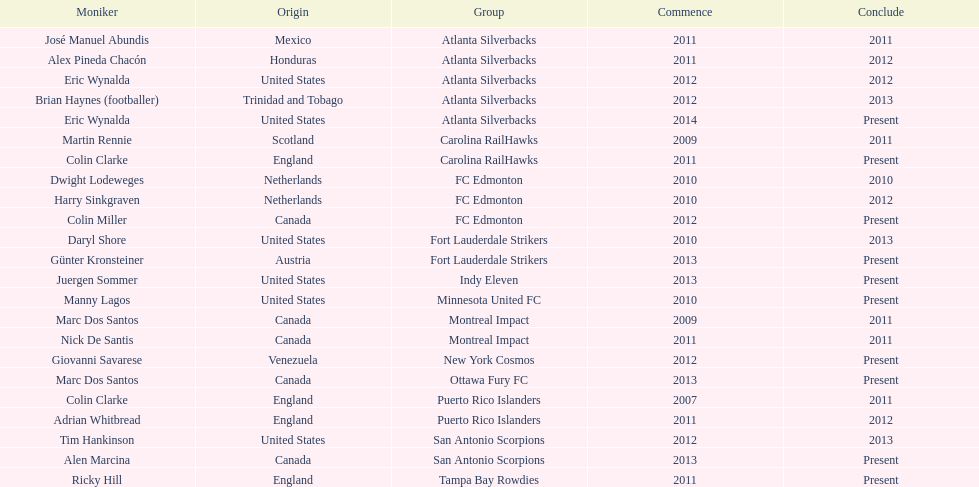What same country did marc dos santos coach as colin miller? Canada. 